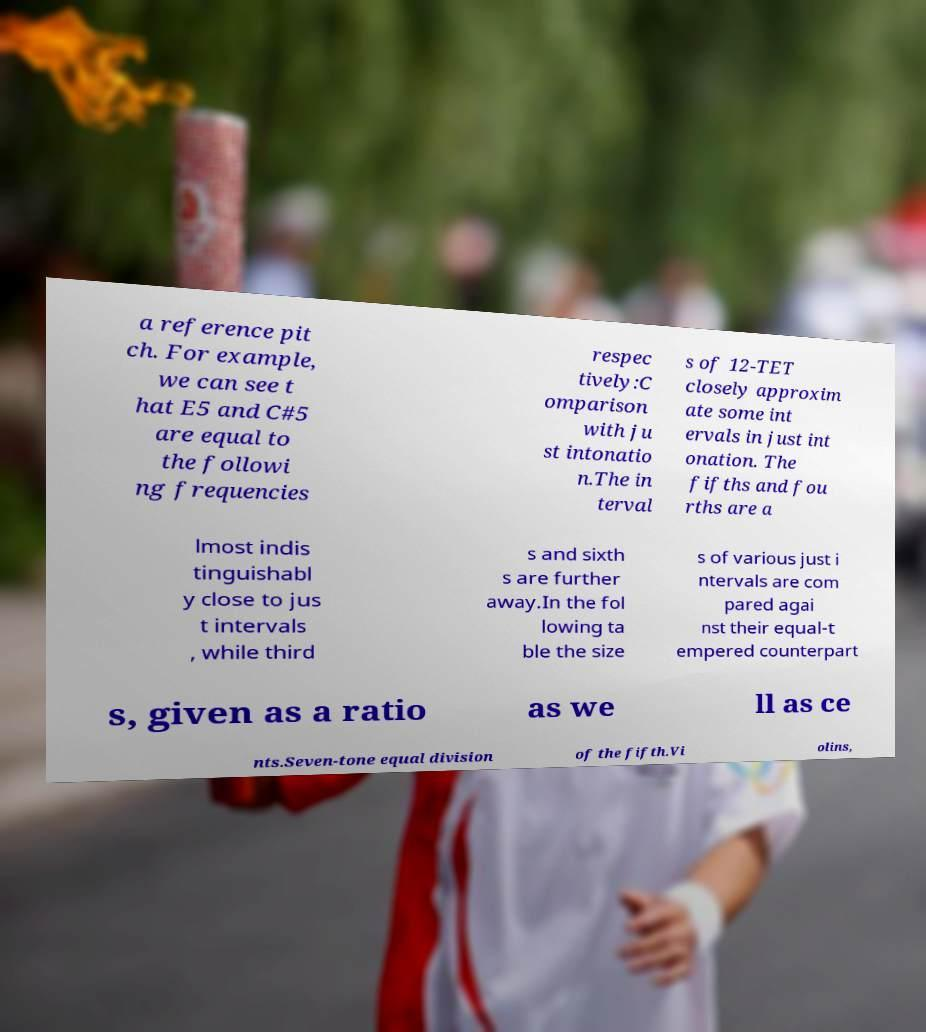Can you accurately transcribe the text from the provided image for me? a reference pit ch. For example, we can see t hat E5 and C#5 are equal to the followi ng frequencies respec tively:C omparison with ju st intonatio n.The in terval s of 12-TET closely approxim ate some int ervals in just int onation. The fifths and fou rths are a lmost indis tinguishabl y close to jus t intervals , while third s and sixth s are further away.In the fol lowing ta ble the size s of various just i ntervals are com pared agai nst their equal-t empered counterpart s, given as a ratio as we ll as ce nts.Seven-tone equal division of the fifth.Vi olins, 